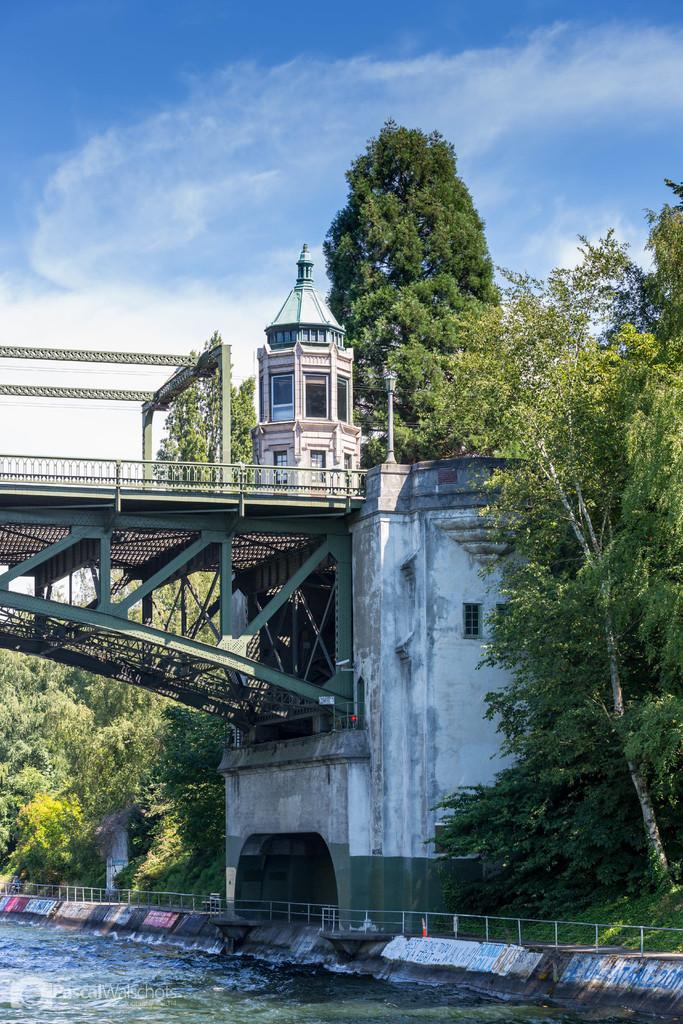What is located at the bottom of the picture? There is a water body at the bottom of the picture. What can be seen in the center of the picture? There are trees and a bridge in the center of the picture. What is being constructed in the center of the picture? There is a construction in the center of the picture. How would you describe the weather in the image? The sky is sunny in the image. Where is the heart-shaped island in the image? There is no heart-shaped island present in the image. How does the construction move around in the image? The construction does not move around in the image; it is stationary. 